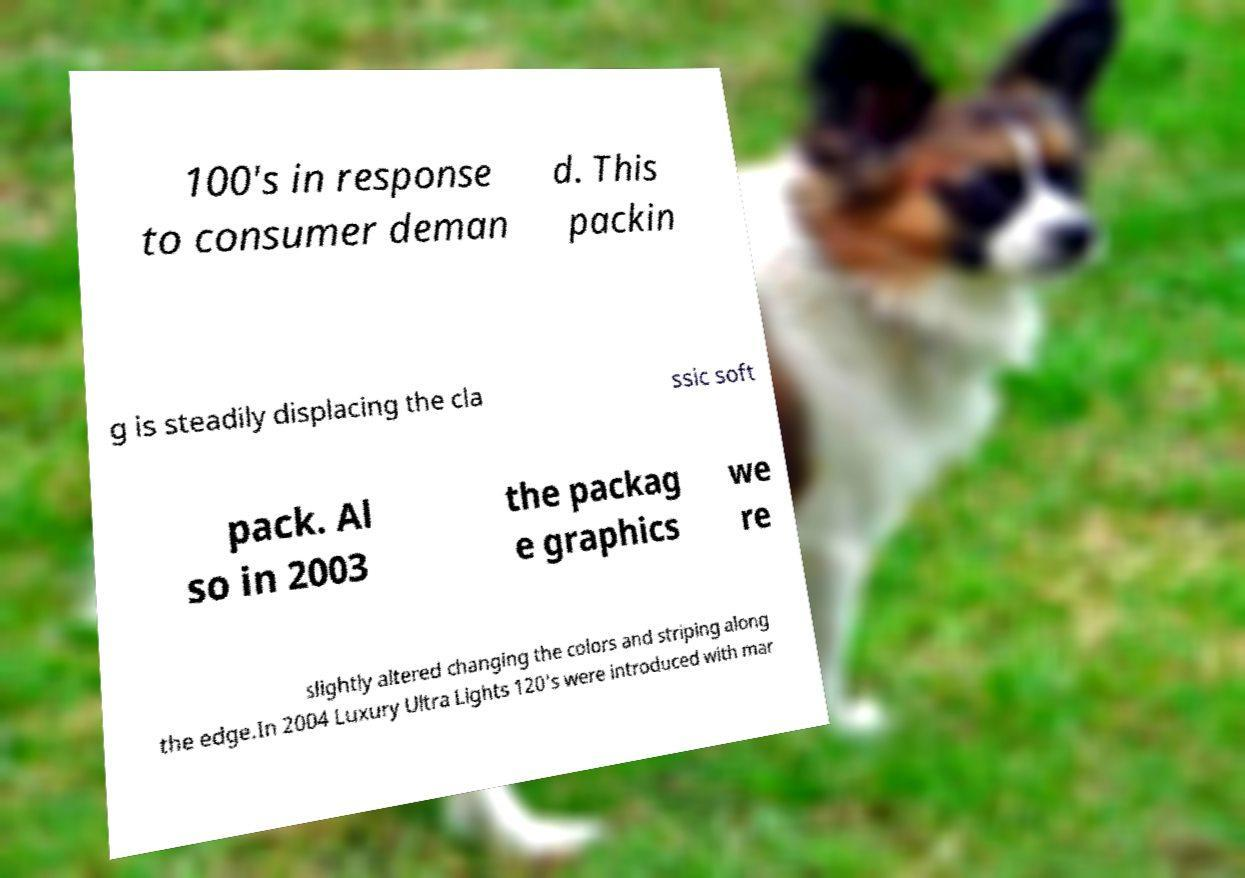What messages or text are displayed in this image? I need them in a readable, typed format. 100's in response to consumer deman d. This packin g is steadily displacing the cla ssic soft pack. Al so in 2003 the packag e graphics we re slightly altered changing the colors and striping along the edge.In 2004 Luxury Ultra Lights 120's were introduced with mar 